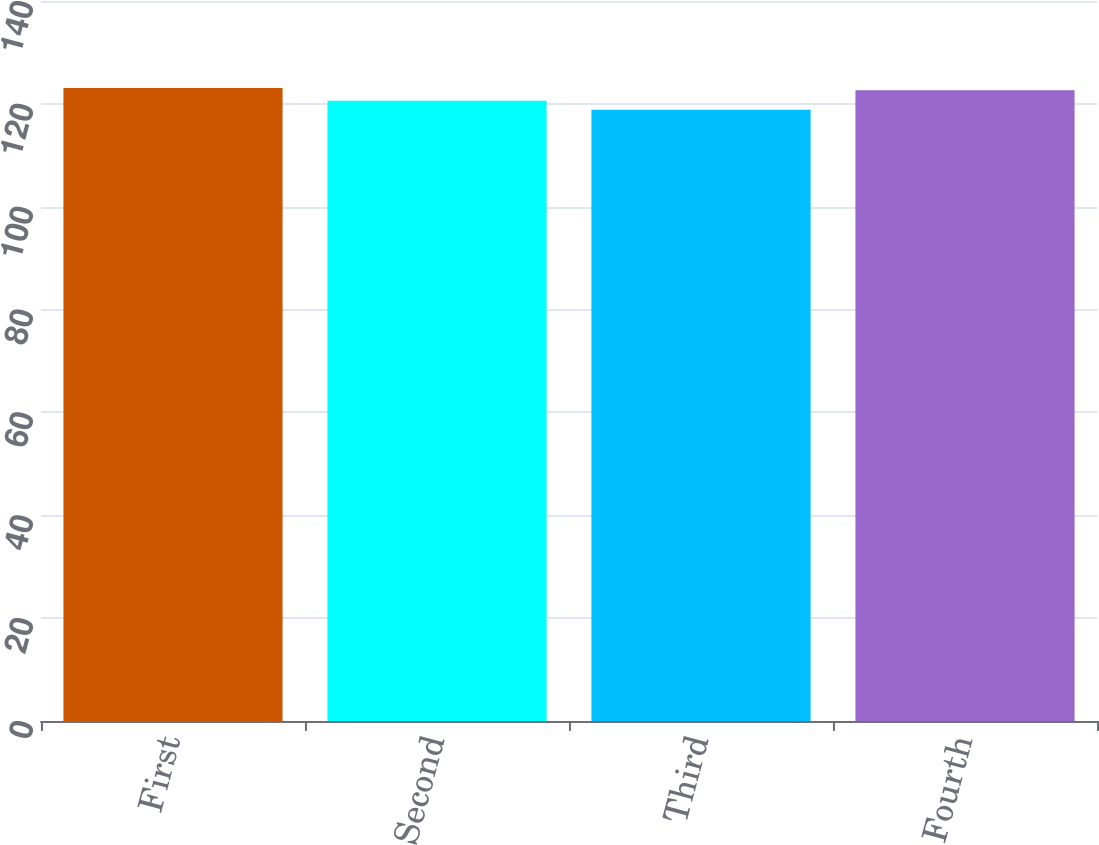Convert chart to OTSL. <chart><loc_0><loc_0><loc_500><loc_500><bar_chart><fcel>First<fcel>Second<fcel>Third<fcel>Fourth<nl><fcel>123.08<fcel>120.61<fcel>118.87<fcel>122.64<nl></chart> 